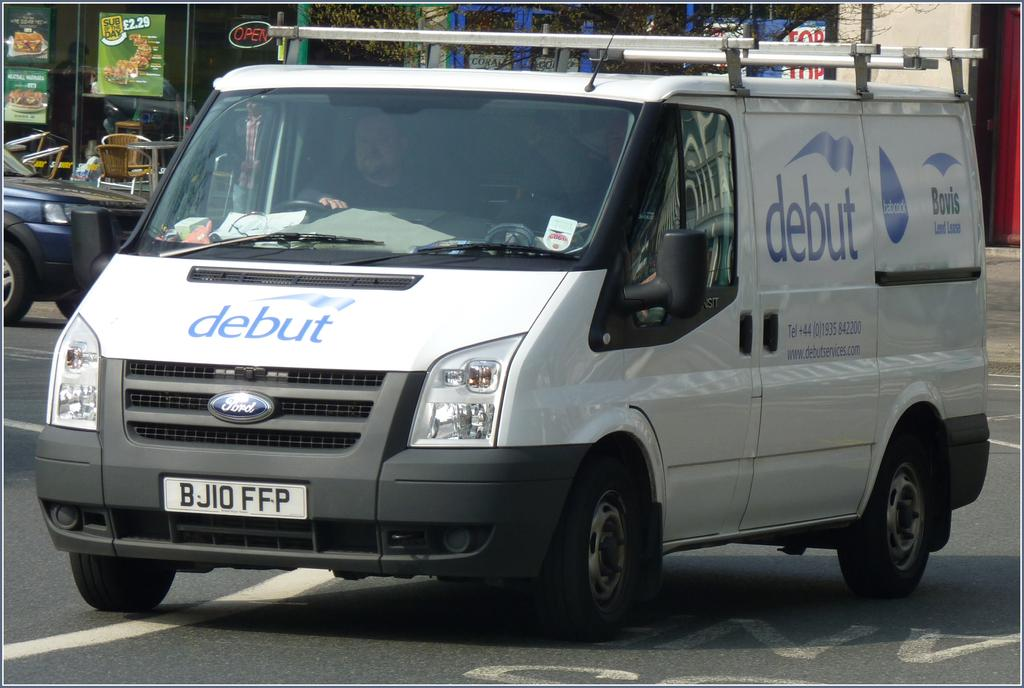<image>
Summarize the visual content of the image. White van which says debut on the front hood. 